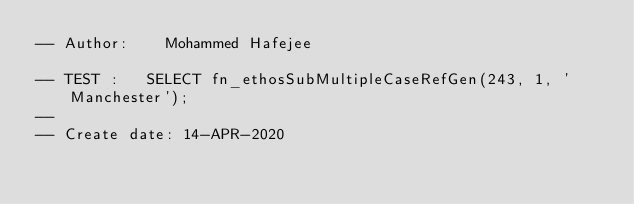<code> <loc_0><loc_0><loc_500><loc_500><_SQL_>-- Author:		Mohammed Hafejee

-- TEST :		SELECT fn_ethosSubMultipleCaseRefGen(243, 1, 'Manchester');
--
-- Create date: 14-APR-2020</code> 